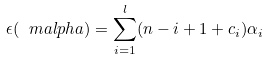<formula> <loc_0><loc_0><loc_500><loc_500>\epsilon ( \ m a l p h a ) = \sum _ { i = 1 } ^ { l } ( n - i + 1 + c _ { i } ) \alpha _ { i }</formula> 